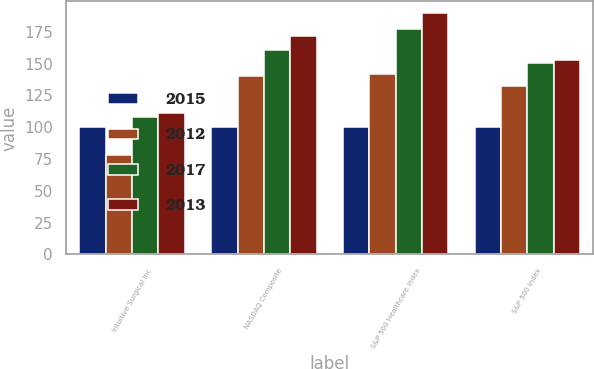Convert chart. <chart><loc_0><loc_0><loc_500><loc_500><stacked_bar_chart><ecel><fcel>Intuitive Surgical Inc<fcel>NASDAQ Composite<fcel>S&P 500 Healthcare Index<fcel>S&P 500 Index<nl><fcel>2015<fcel>100<fcel>100<fcel>100<fcel>100<nl><fcel>2012<fcel>78.32<fcel>140.12<fcel>141.46<fcel>132.39<nl><fcel>2017<fcel>107.87<fcel>160.78<fcel>177.3<fcel>150.51<nl><fcel>2013<fcel>111.38<fcel>171.97<fcel>189.52<fcel>152.59<nl></chart> 